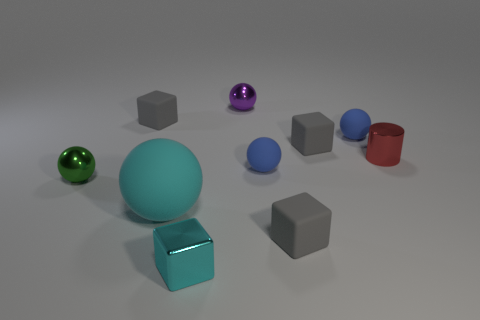Are there any small green metal things? Yes, there is a small green sphere that appears to have a metallic finish. 